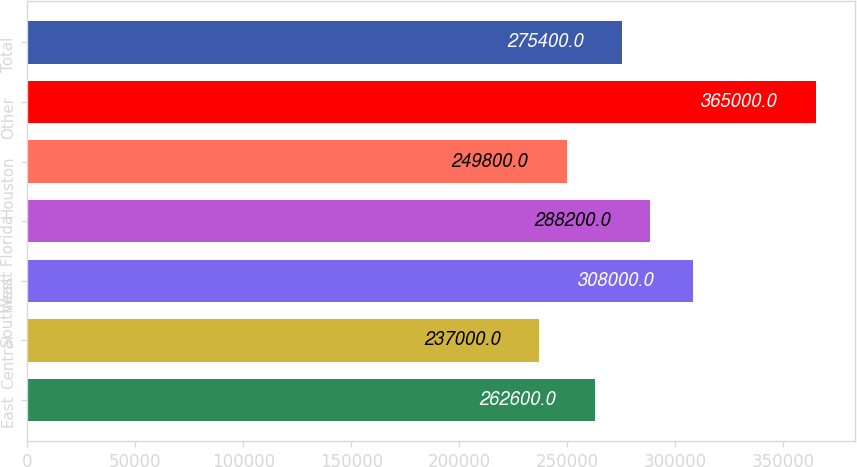Convert chart to OTSL. <chart><loc_0><loc_0><loc_500><loc_500><bar_chart><fcel>East<fcel>Central<fcel>West<fcel>Southeast Florida<fcel>Houston<fcel>Other<fcel>Total<nl><fcel>262600<fcel>237000<fcel>308000<fcel>288200<fcel>249800<fcel>365000<fcel>275400<nl></chart> 